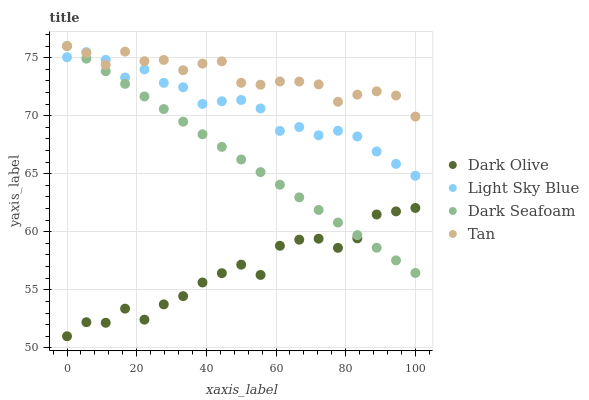Does Dark Olive have the minimum area under the curve?
Answer yes or no. Yes. Does Tan have the maximum area under the curve?
Answer yes or no. Yes. Does Tan have the minimum area under the curve?
Answer yes or no. No. Does Dark Olive have the maximum area under the curve?
Answer yes or no. No. Is Dark Seafoam the smoothest?
Answer yes or no. Yes. Is Dark Olive the roughest?
Answer yes or no. Yes. Is Tan the smoothest?
Answer yes or no. No. Is Tan the roughest?
Answer yes or no. No. Does Dark Olive have the lowest value?
Answer yes or no. Yes. Does Tan have the lowest value?
Answer yes or no. No. Does Tan have the highest value?
Answer yes or no. Yes. Does Dark Olive have the highest value?
Answer yes or no. No. Is Dark Olive less than Light Sky Blue?
Answer yes or no. Yes. Is Light Sky Blue greater than Dark Olive?
Answer yes or no. Yes. Does Tan intersect Dark Seafoam?
Answer yes or no. Yes. Is Tan less than Dark Seafoam?
Answer yes or no. No. Is Tan greater than Dark Seafoam?
Answer yes or no. No. Does Dark Olive intersect Light Sky Blue?
Answer yes or no. No. 